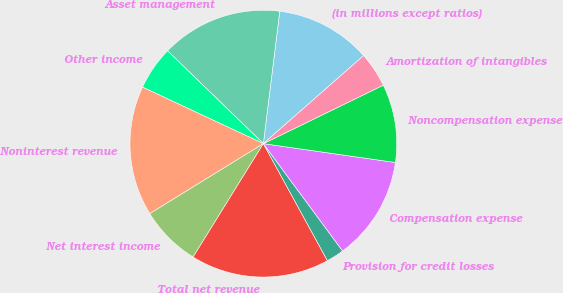<chart> <loc_0><loc_0><loc_500><loc_500><pie_chart><fcel>(in millions except ratios)<fcel>Asset management<fcel>Other income<fcel>Noninterest revenue<fcel>Net interest income<fcel>Total net revenue<fcel>Provision for credit losses<fcel>Compensation expense<fcel>Noncompensation expense<fcel>Amortization of intangibles<nl><fcel>11.57%<fcel>14.71%<fcel>5.29%<fcel>15.75%<fcel>7.38%<fcel>16.8%<fcel>2.15%<fcel>12.62%<fcel>9.48%<fcel>4.25%<nl></chart> 